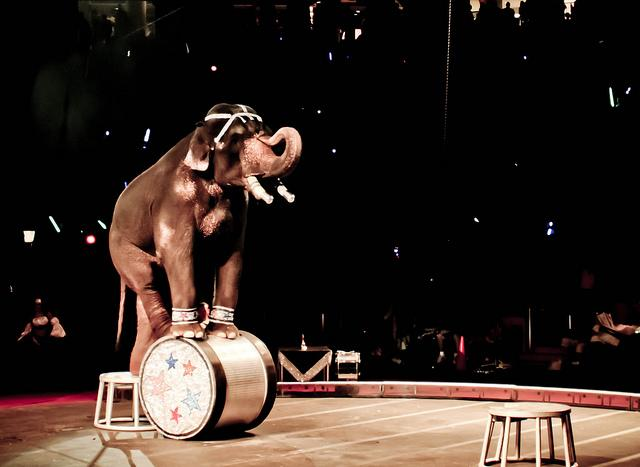Why is the elephant placing its legs on the wheel? Please explain your reasoning. to mount. The elephant is trying to mount. 